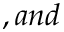Convert formula to latex. <formula><loc_0><loc_0><loc_500><loc_500>, a n d</formula> 